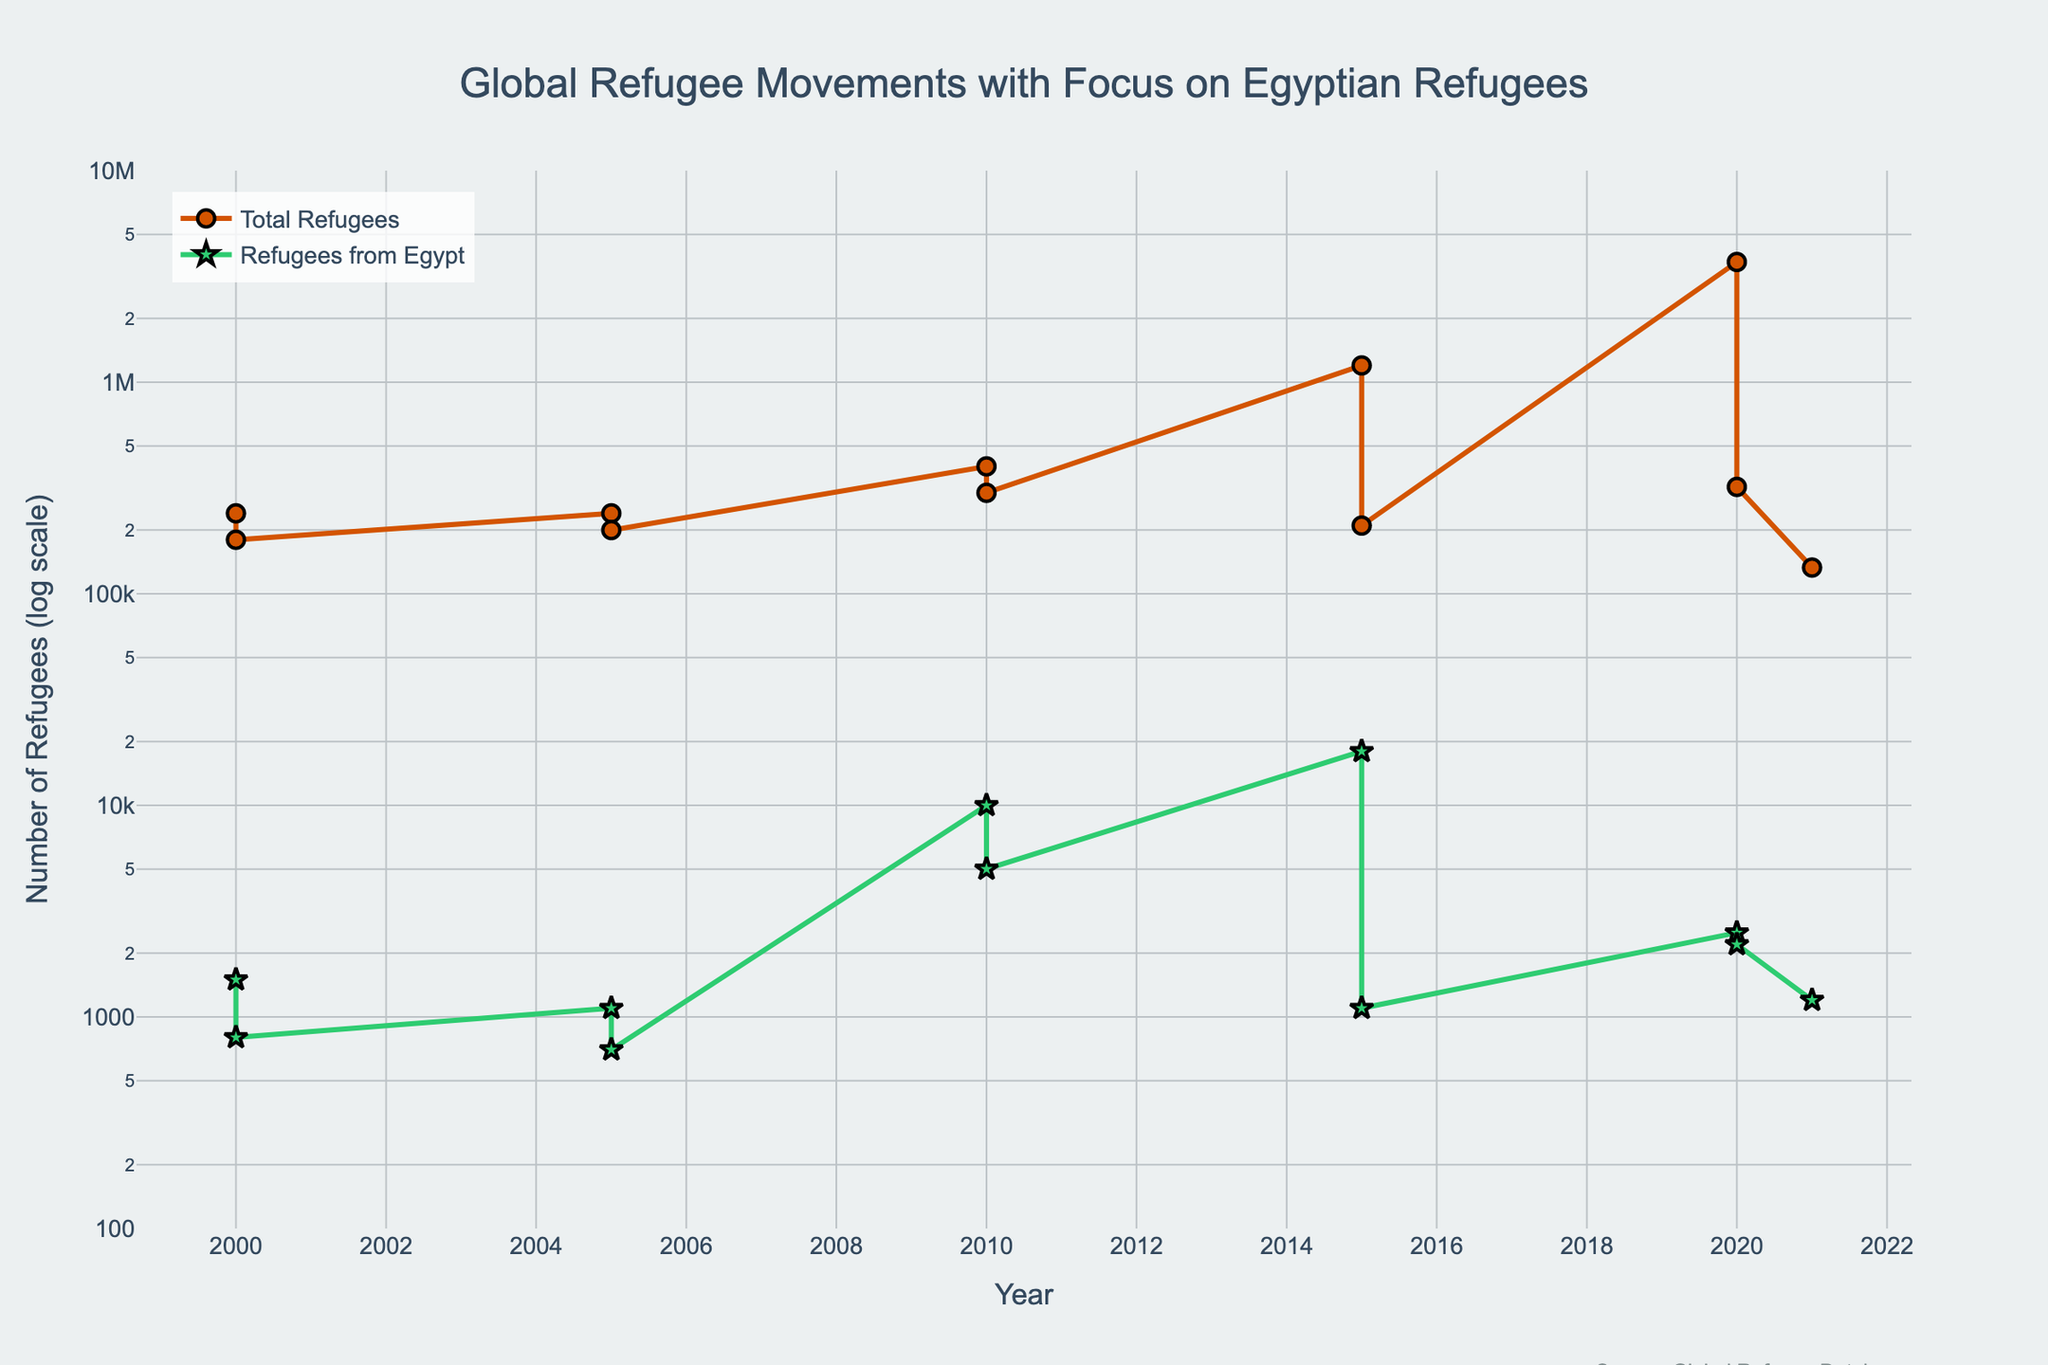What is the title of the plot? The title of the plot is prominently written at the top of the figure. It provides a quick summary of what the plot represents.
Answer: Global Refugee Movements with Focus on Egyptian Refugees What is the unit displayed on the y-axis? The y-axis label indicates the unit used to measure the data points plotted.
Answer: Number of Refugees (log scale) How many countries are represented in the data for the year 2020? By observing the markers on the plot for the year 2020, one can count the number of distinct markers which represent different countries.
Answer: Two countries What trend can be observed for the number of total refugees in Germany from 2005 to 2015? To observe the trend, look at the markers and lines for Germany in the years 2005 and 2015 on the plot. There's an upward trajectory in the number of total refugees.
Answer: The number of total refugees significantly increased Which year saw the highest number of total refugees in Turkey? By examining the plot and locating the highest marker for Turkey over the years, you can identify the peak year.
Answer: 2020 Between which years did the United States see a noticeable change in the number of total refugees? By looking at the markers for the United States over various years, any noticeable changes in trend can be identified.
Answer: Between 2020 and 2021 What is the difference in the number of refugees from Egypt between 2000 and 2010? From the plot, note the number at the markers for Egypt in 2000 and in 2010, then calculate the difference.
Answer: 10000 - 1500 = 8500 Comparing Germany and Canada, which country had more Egyptian refugees in 2015? By looking at the markers on the plot for Germany and Canada for the year 2015, you can compare the numbers for Egyptian refugees.
Answer: Germany What pattern can be observed in the number of total refugees globally from 2000 to 2020? By examining the plot's overall trend line for the "Total Refugees" category over the years, a general trend can be observed.
Answer: Increasing trend 